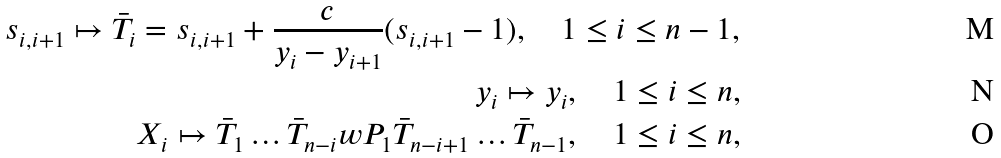Convert formula to latex. <formula><loc_0><loc_0><loc_500><loc_500>s _ { i , i + 1 } \mapsto \bar { T } _ { i } = s _ { i , i + 1 } + \frac { c } { y _ { i } - y _ { i + 1 } } ( s _ { i , i + 1 } - 1 ) , \quad 1 \leq i \leq n - 1 , \\ y _ { i } \mapsto y _ { i } , \quad 1 \leq i \leq n , \\ X _ { i } \mapsto \bar { T } _ { 1 } \dots \bar { T } _ { n - i } w P _ { 1 } \bar { T } _ { n - i + 1 } \dots \bar { T } _ { n - 1 } , \quad 1 \leq i \leq n ,</formula> 